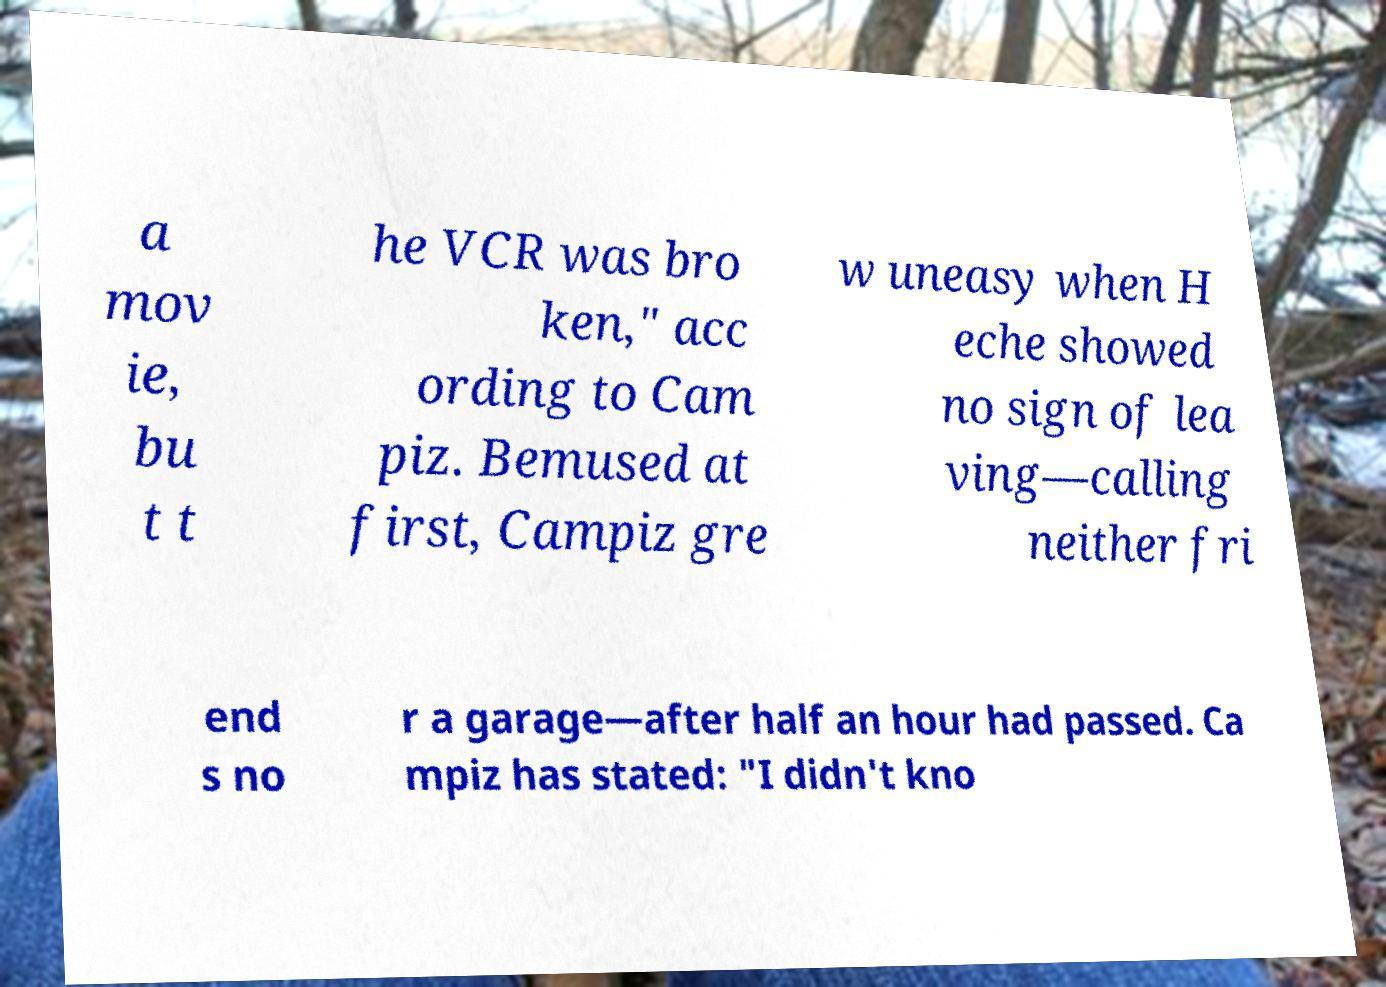I need the written content from this picture converted into text. Can you do that? a mov ie, bu t t he VCR was bro ken," acc ording to Cam piz. Bemused at first, Campiz gre w uneasy when H eche showed no sign of lea ving—calling neither fri end s no r a garage—after half an hour had passed. Ca mpiz has stated: "I didn't kno 